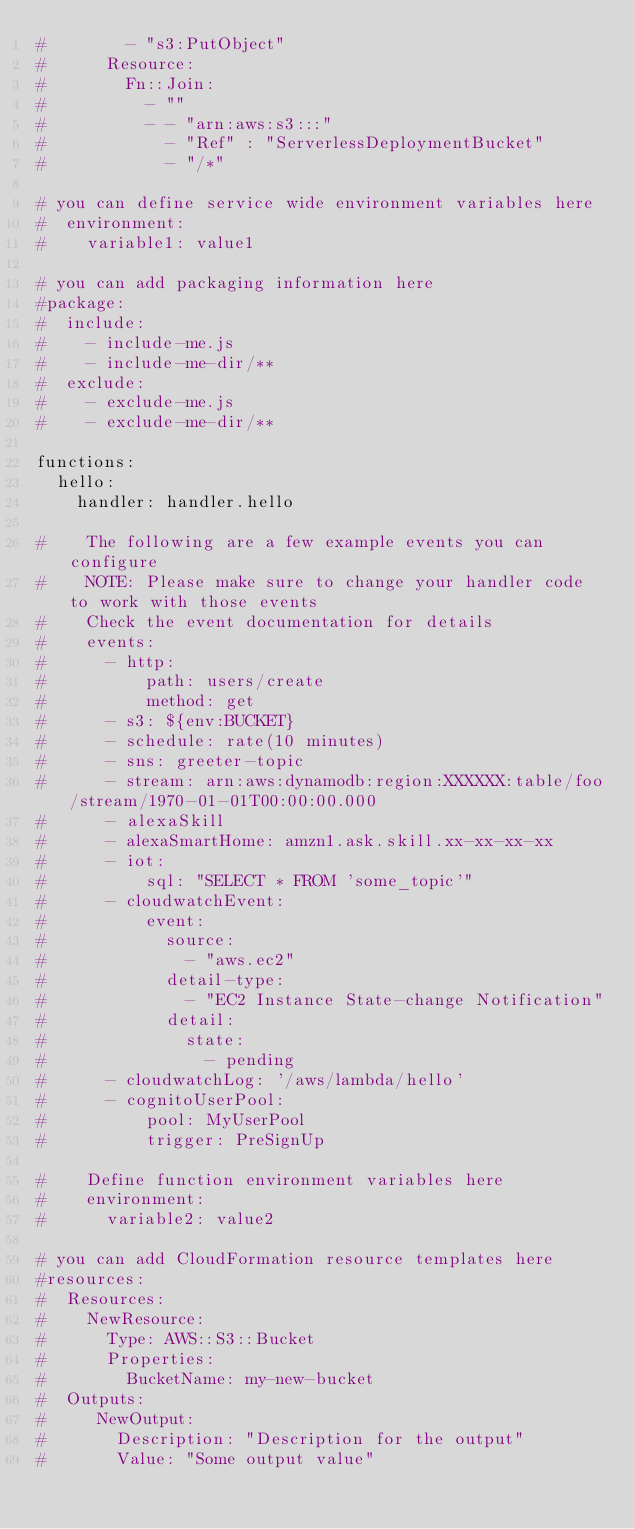Convert code to text. <code><loc_0><loc_0><loc_500><loc_500><_YAML_>#        - "s3:PutObject"
#      Resource:
#        Fn::Join:
#          - ""
#          - - "arn:aws:s3:::"
#            - "Ref" : "ServerlessDeploymentBucket"
#            - "/*"

# you can define service wide environment variables here
#  environment:
#    variable1: value1

# you can add packaging information here
#package:
#  include:
#    - include-me.js
#    - include-me-dir/**
#  exclude:
#    - exclude-me.js
#    - exclude-me-dir/**

functions:
  hello:
    handler: handler.hello

#    The following are a few example events you can configure
#    NOTE: Please make sure to change your handler code to work with those events
#    Check the event documentation for details
#    events:
#      - http:
#          path: users/create
#          method: get
#      - s3: ${env:BUCKET}
#      - schedule: rate(10 minutes)
#      - sns: greeter-topic
#      - stream: arn:aws:dynamodb:region:XXXXXX:table/foo/stream/1970-01-01T00:00:00.000
#      - alexaSkill
#      - alexaSmartHome: amzn1.ask.skill.xx-xx-xx-xx
#      - iot:
#          sql: "SELECT * FROM 'some_topic'"
#      - cloudwatchEvent:
#          event:
#            source:
#              - "aws.ec2"
#            detail-type:
#              - "EC2 Instance State-change Notification"
#            detail:
#              state:
#                - pending
#      - cloudwatchLog: '/aws/lambda/hello'
#      - cognitoUserPool:
#          pool: MyUserPool
#          trigger: PreSignUp

#    Define function environment variables here
#    environment:
#      variable2: value2

# you can add CloudFormation resource templates here
#resources:
#  Resources:
#    NewResource:
#      Type: AWS::S3::Bucket
#      Properties:
#        BucketName: my-new-bucket
#  Outputs:
#     NewOutput:
#       Description: "Description for the output"
#       Value: "Some output value"
</code> 